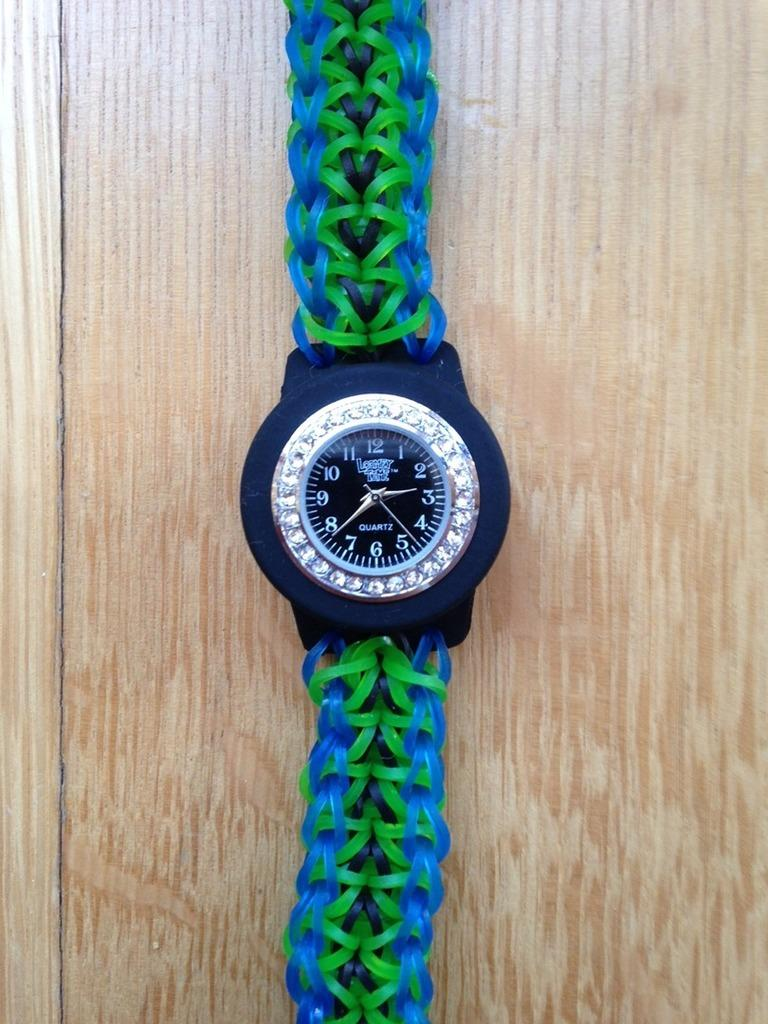<image>
Provide a brief description of the given image. A watch with a band of interwoven plastic bands shows the time as 2:39. 